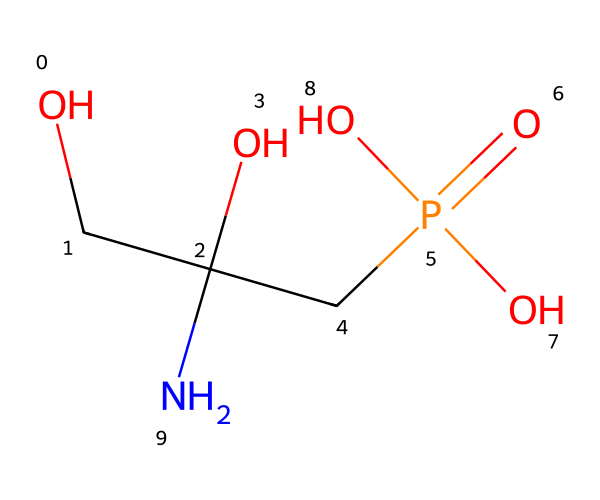What is the molecular formula of glyphosate? To determine the molecular formula, we need to count each type of atom in the SMILES representation. The SMILES "OCC(O)(CP(=O)(O)O)N" indicates there are 3 carbon atoms (C), 11 hydrogen atoms (H), 4 oxygen atoms (O), and 1 nitrogen atom (N). Therefore, the molecular formula is C3H11N2O4P.
Answer: C3H11N2O4P How many nitrogen atoms are present in glyphosate? By examining the SMILES representation, we see there is only one "N" in the structure. Thus, glyphosate contains one nitrogen atom.
Answer: 1 What type of functional group is present in glyphosate responsible for its herbicidal activity? The chemical structure contains a phosphate group (P(=O)(O)O) which is critical in acting as a herbicide. This group is associated with the herbicidal properties of glyphosate.
Answer: phosphate group What is the total number of oxygen atoms in glyphosate? Reviewing the SMILES structure reveals that there are four "O"s indicated in the phosphate group and hydroxyl groups. Counting these gives a total of four oxygen atoms.
Answer: 4 What does the presence of the nitrogen atom in glyphosate suggest about its properties? The presence of the nitrogen atom in glyphosate indicates it has amino characteristics which can influence its solubility and interaction with biological targets, enhancing its effectiveness as a herbicide.
Answer: amino characteristics What type of pesticide is glyphosate classified as? Glyphosate is classified as a non-selective herbicide because it kills a wide variety of plants by inhibiting a specific enzyme pathway. This classification is derived from its chemical structure affecting various plants.
Answer: non-selective herbicide How does glyphosate's structure affect its solubility in water? Glyphosate contains both hydrophilic (water-attracting) functional groups like hydroxyl (-OH) and phosphate, which enhance its solubility in water, making it more effective for application.
Answer: enhances solubility 